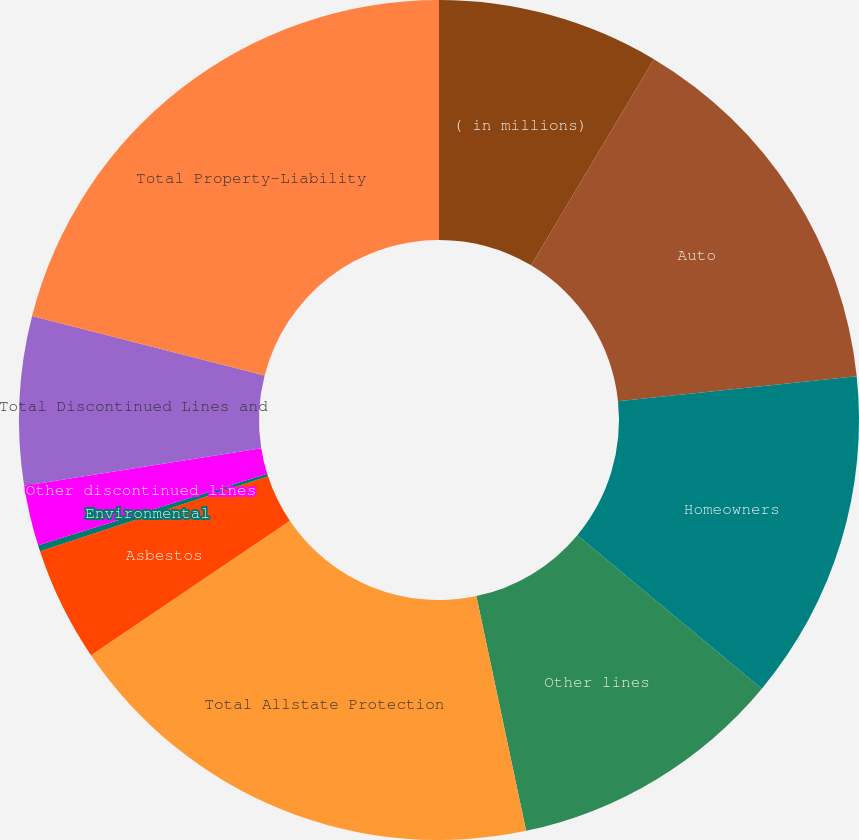Convert chart to OTSL. <chart><loc_0><loc_0><loc_500><loc_500><pie_chart><fcel>( in millions)<fcel>Auto<fcel>Homeowners<fcel>Other lines<fcel>Total Allstate Protection<fcel>Asbestos<fcel>Environmental<fcel>Other discontinued lines<fcel>Total Discontinued Lines and<fcel>Total Property-Liability<nl><fcel>8.55%<fcel>14.79%<fcel>12.71%<fcel>10.63%<fcel>18.87%<fcel>4.4%<fcel>0.24%<fcel>2.32%<fcel>6.48%<fcel>21.02%<nl></chart> 